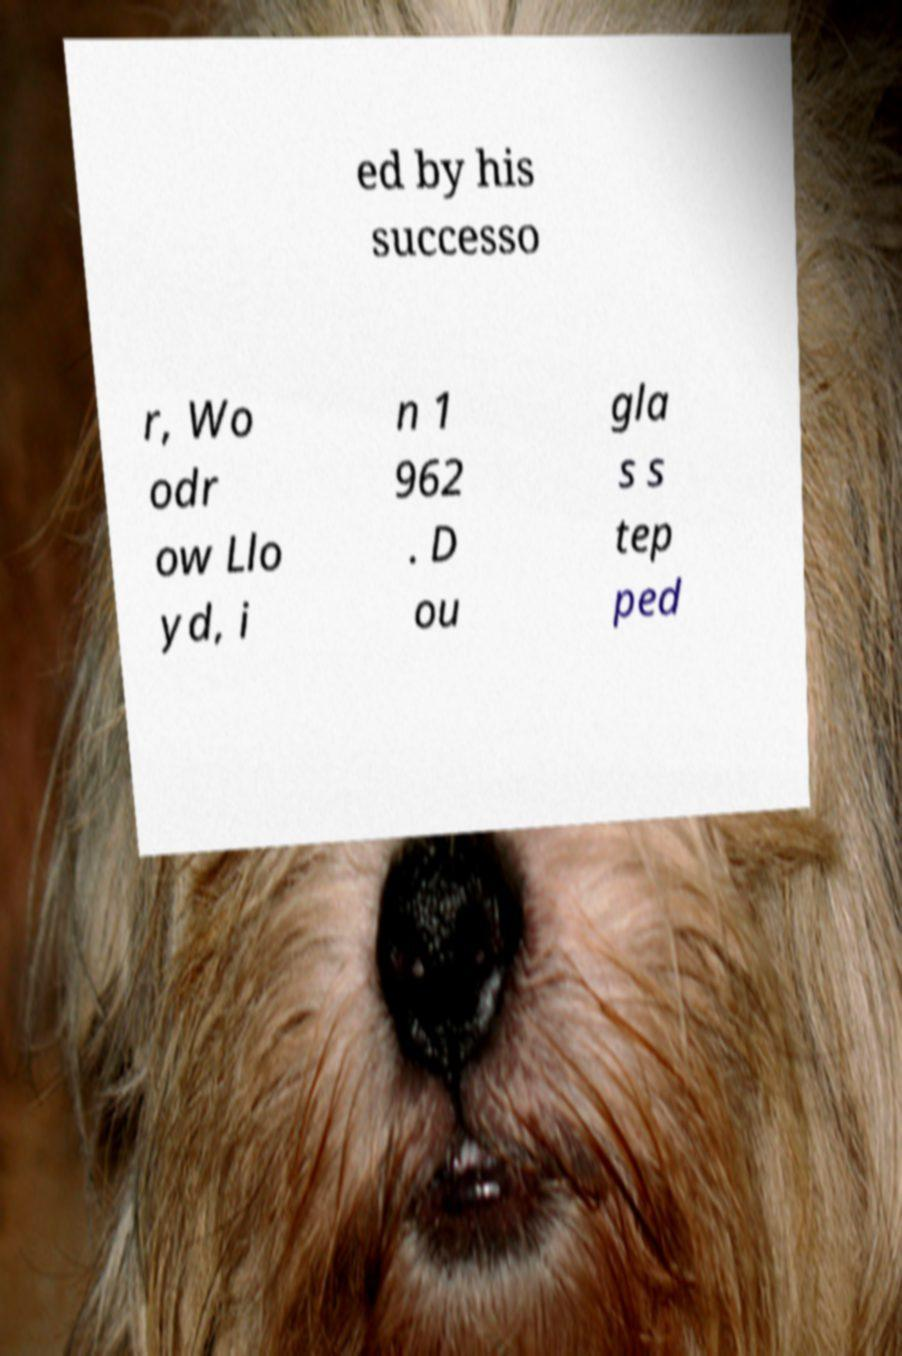For documentation purposes, I need the text within this image transcribed. Could you provide that? ed by his successo r, Wo odr ow Llo yd, i n 1 962 . D ou gla s s tep ped 